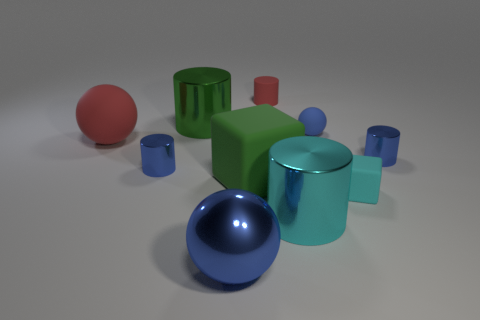Subtract all tiny red matte cylinders. How many cylinders are left? 4 Subtract all red cylinders. How many cylinders are left? 4 Subtract 1 cylinders. How many cylinders are left? 4 Subtract all yellow cylinders. Subtract all gray blocks. How many cylinders are left? 5 Subtract all cubes. How many objects are left? 8 Add 7 yellow matte cylinders. How many yellow matte cylinders exist? 7 Subtract 0 purple blocks. How many objects are left? 10 Subtract all large purple rubber things. Subtract all big blocks. How many objects are left? 9 Add 2 small red matte objects. How many small red matte objects are left? 3 